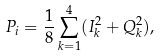Convert formula to latex. <formula><loc_0><loc_0><loc_500><loc_500>P _ { i } = \frac { 1 } { 8 } \sum _ { k = 1 } ^ { 4 } ( I _ { k } ^ { 2 } + Q _ { k } ^ { 2 } ) ,</formula> 